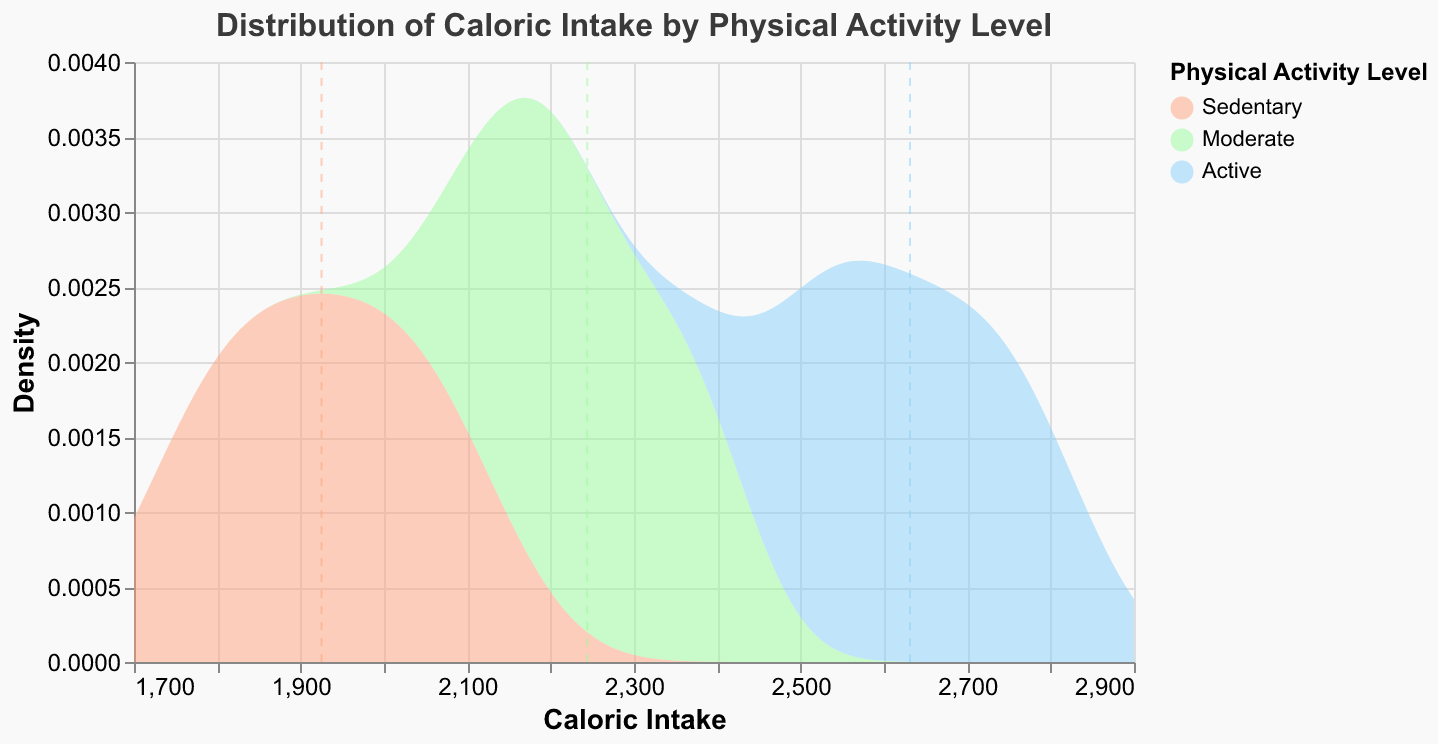What is the title of the figure? The title of the figure is the text displayed prominently at the top. It is an essential element as it provides the reader with the context of the visualization.
Answer: Distribution of Caloric Intake by Physical Activity Level What does the x-axis represent? The x-axis typically represents the independent variable in a distribution plot. In this figure, it indicates the range of caloric intakes measured.
Answer: Caloric Intake Which color represents the "Active" physical activity level? The "Active" physical activity level is indicated by the specific color used in the plot. The legend helps identify this color.
Answer: Light blue Which physical activity level has the highest mean caloric intake? The mean caloric intake for each physical activity level can be inferred from the dashed vertical lines. The position of these lines, marked for each group, indicates the mean value.
Answer: Active How do the caloric intake densities compare between "Sedentary" and "Active" levels? To compare the densities, observe the height and shape of the curves for the "Sedentary" and "Active" groups. The "Sedentary" group's curve is more leftward and has its peak at lower caloric values compared to the "Active" group, whose curve peaks higher and at larger caloric intake values.
Answer: The "Active" group has a higher density peak at higher caloric intakes compared to the "Sedentary" group What can be inferred about the caloric intake range for the "Moderate" activity level? Observe the spread of the density curve for the "Moderate" activity level. The range at which the curve exists provides the information on the caloric intake distribution.
Answer: 2100 to 2400 calories Describe the distribution shape for the "Sedentary" group. The shape of the distribution for the "Sedentary" group can be observed by looking at the curve's peak and spread. Its form can indicate whether it's symmetric, skewed, etc.
Answer: Symmetrical and unimodal with a peak around 1900-2000 calories Which physical activity level shows the most variation in caloric intake? Variation can be interpreted by looking at the width of the density curves. A wider curve indicates more variability in caloric intake.
Answer: Active What are the approximate mean caloric intakes for "Sedentary" and "Moderate" activity levels, and how do they compare? The dashed lines give the mean caloric intake for each group. By examining the positions of these lines on the x-axis, we estimate the mean values. Comparing these values gives insights into how they differ.
Answer: Sedentary: ~1950, Moderate: ~2250; Moderate is higher by ~300 calories 